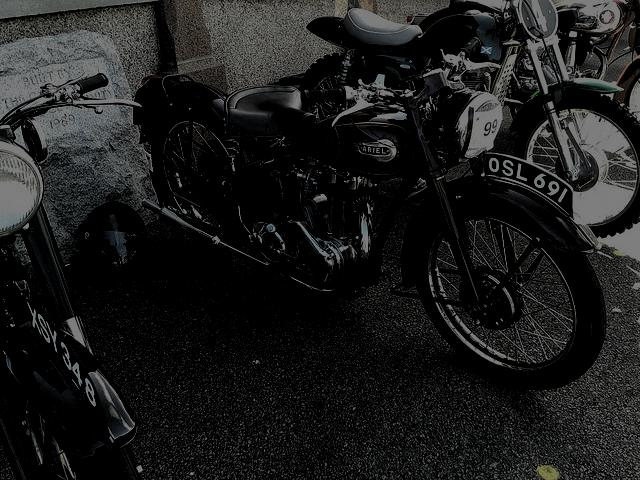Can you tell me more about the design of this motorcycle? The motorcycle in the image is a classic model, with a distinctive retro design. It features a simple, rounded fuel tank, a single sprung saddle seat, and a prominent headlamp. The engine appears to be a parallel-twin, which suggests it could be a British make from the mid-20th century. The spokes on the wheels and the rigid frame are also indicative of its vintage heritage. 